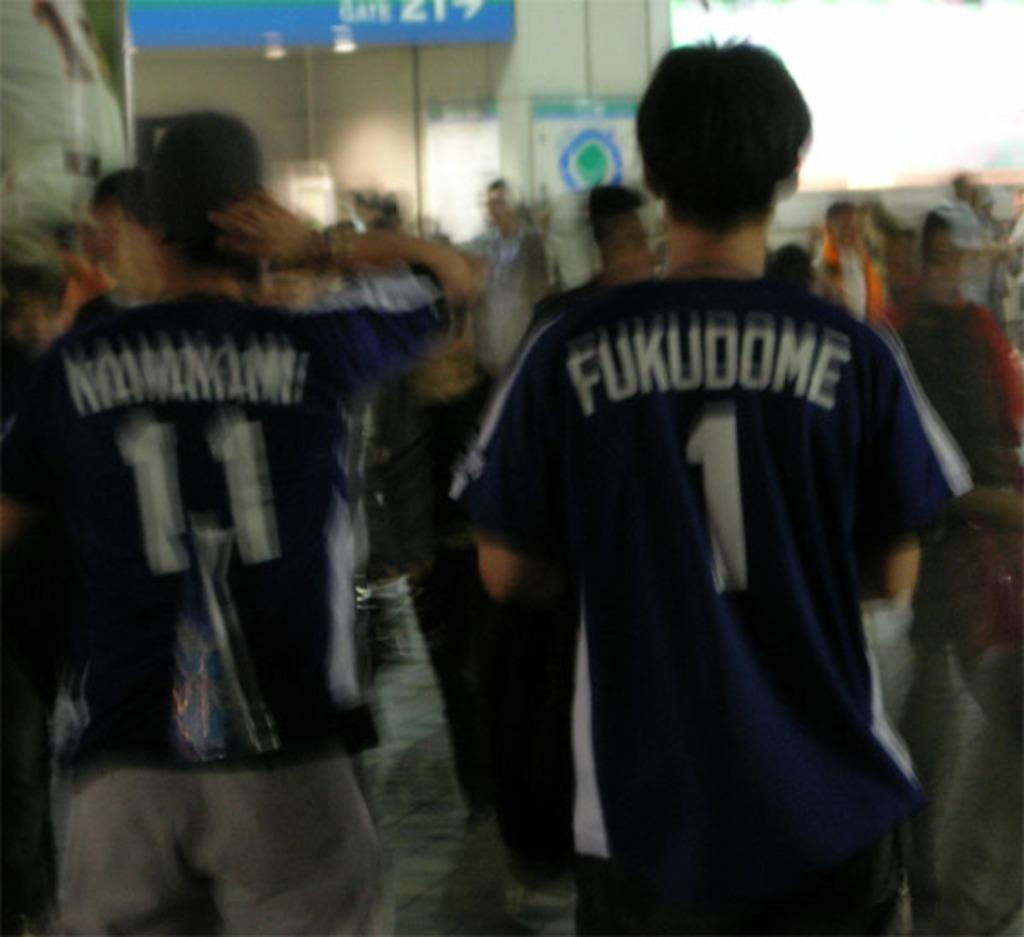<image>
Relay a brief, clear account of the picture shown. blurry people wear Fukudome 1 and 11 shirts 